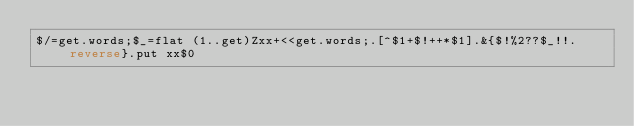Convert code to text. <code><loc_0><loc_0><loc_500><loc_500><_Perl_>$/=get.words;$_=flat (1..get)Zxx+<<get.words;.[^$1+$!++*$1].&{$!%2??$_!!.reverse}.put xx$0</code> 